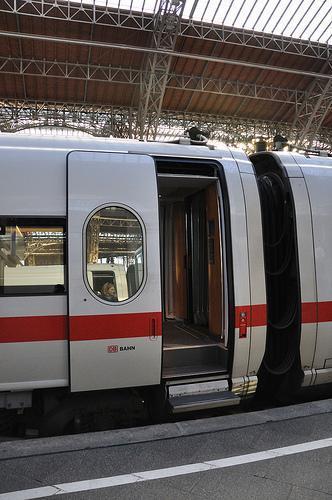How many people are there?
Give a very brief answer. 1. 